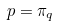<formula> <loc_0><loc_0><loc_500><loc_500>p = \pi _ { q }</formula> 